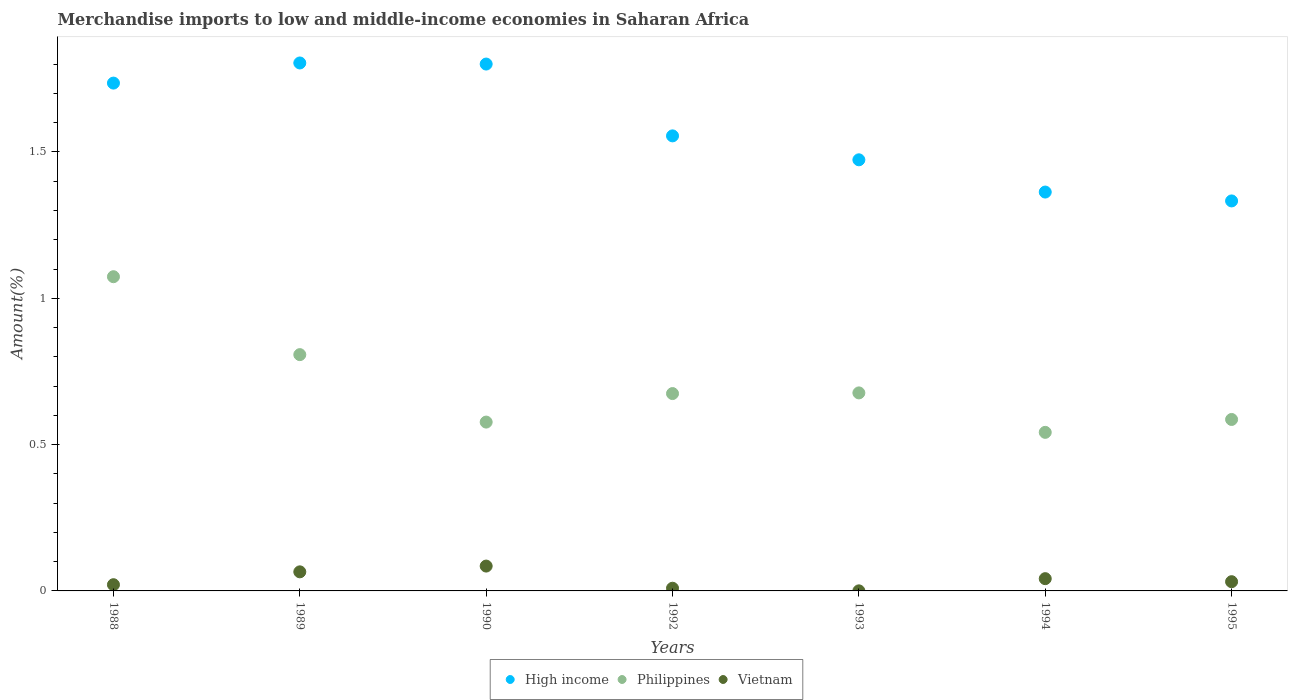How many different coloured dotlines are there?
Provide a short and direct response. 3. Is the number of dotlines equal to the number of legend labels?
Your answer should be compact. Yes. What is the percentage of amount earned from merchandise imports in High income in 1988?
Keep it short and to the point. 1.74. Across all years, what is the maximum percentage of amount earned from merchandise imports in Philippines?
Your response must be concise. 1.07. Across all years, what is the minimum percentage of amount earned from merchandise imports in Vietnam?
Your answer should be compact. 0. What is the total percentage of amount earned from merchandise imports in High income in the graph?
Offer a terse response. 11.06. What is the difference between the percentage of amount earned from merchandise imports in Vietnam in 1989 and that in 1992?
Your answer should be compact. 0.06. What is the difference between the percentage of amount earned from merchandise imports in High income in 1994 and the percentage of amount earned from merchandise imports in Vietnam in 1992?
Provide a succinct answer. 1.35. What is the average percentage of amount earned from merchandise imports in High income per year?
Your answer should be compact. 1.58. In the year 1993, what is the difference between the percentage of amount earned from merchandise imports in Vietnam and percentage of amount earned from merchandise imports in Philippines?
Offer a very short reply. -0.68. In how many years, is the percentage of amount earned from merchandise imports in Vietnam greater than 1.6 %?
Provide a succinct answer. 0. What is the ratio of the percentage of amount earned from merchandise imports in High income in 1988 to that in 1993?
Make the answer very short. 1.18. What is the difference between the highest and the second highest percentage of amount earned from merchandise imports in Vietnam?
Provide a short and direct response. 0.02. What is the difference between the highest and the lowest percentage of amount earned from merchandise imports in Vietnam?
Your answer should be compact. 0.08. How many years are there in the graph?
Your response must be concise. 7. Does the graph contain any zero values?
Give a very brief answer. No. Does the graph contain grids?
Your answer should be very brief. No. Where does the legend appear in the graph?
Your answer should be compact. Bottom center. How many legend labels are there?
Give a very brief answer. 3. How are the legend labels stacked?
Make the answer very short. Horizontal. What is the title of the graph?
Your response must be concise. Merchandise imports to low and middle-income economies in Saharan Africa. What is the label or title of the Y-axis?
Provide a succinct answer. Amount(%). What is the Amount(%) in High income in 1988?
Keep it short and to the point. 1.74. What is the Amount(%) of Philippines in 1988?
Give a very brief answer. 1.07. What is the Amount(%) in Vietnam in 1988?
Your response must be concise. 0.02. What is the Amount(%) in High income in 1989?
Provide a short and direct response. 1.8. What is the Amount(%) of Philippines in 1989?
Provide a succinct answer. 0.81. What is the Amount(%) in Vietnam in 1989?
Your answer should be compact. 0.07. What is the Amount(%) of High income in 1990?
Make the answer very short. 1.8. What is the Amount(%) in Philippines in 1990?
Your answer should be very brief. 0.58. What is the Amount(%) of Vietnam in 1990?
Give a very brief answer. 0.08. What is the Amount(%) of High income in 1992?
Ensure brevity in your answer.  1.56. What is the Amount(%) of Philippines in 1992?
Offer a terse response. 0.67. What is the Amount(%) of Vietnam in 1992?
Make the answer very short. 0.01. What is the Amount(%) of High income in 1993?
Give a very brief answer. 1.47. What is the Amount(%) of Philippines in 1993?
Ensure brevity in your answer.  0.68. What is the Amount(%) in Vietnam in 1993?
Provide a short and direct response. 0. What is the Amount(%) of High income in 1994?
Your answer should be compact. 1.36. What is the Amount(%) in Philippines in 1994?
Offer a terse response. 0.54. What is the Amount(%) in Vietnam in 1994?
Your answer should be compact. 0.04. What is the Amount(%) of High income in 1995?
Give a very brief answer. 1.33. What is the Amount(%) in Philippines in 1995?
Keep it short and to the point. 0.59. What is the Amount(%) in Vietnam in 1995?
Give a very brief answer. 0.03. Across all years, what is the maximum Amount(%) in High income?
Offer a very short reply. 1.8. Across all years, what is the maximum Amount(%) of Philippines?
Keep it short and to the point. 1.07. Across all years, what is the maximum Amount(%) in Vietnam?
Make the answer very short. 0.08. Across all years, what is the minimum Amount(%) in High income?
Make the answer very short. 1.33. Across all years, what is the minimum Amount(%) in Philippines?
Make the answer very short. 0.54. Across all years, what is the minimum Amount(%) of Vietnam?
Your answer should be compact. 0. What is the total Amount(%) in High income in the graph?
Give a very brief answer. 11.06. What is the total Amount(%) of Philippines in the graph?
Ensure brevity in your answer.  4.94. What is the total Amount(%) in Vietnam in the graph?
Provide a succinct answer. 0.25. What is the difference between the Amount(%) of High income in 1988 and that in 1989?
Provide a succinct answer. -0.07. What is the difference between the Amount(%) in Philippines in 1988 and that in 1989?
Offer a very short reply. 0.27. What is the difference between the Amount(%) in Vietnam in 1988 and that in 1989?
Provide a short and direct response. -0.04. What is the difference between the Amount(%) in High income in 1988 and that in 1990?
Make the answer very short. -0.07. What is the difference between the Amount(%) in Philippines in 1988 and that in 1990?
Give a very brief answer. 0.5. What is the difference between the Amount(%) of Vietnam in 1988 and that in 1990?
Offer a terse response. -0.06. What is the difference between the Amount(%) of High income in 1988 and that in 1992?
Keep it short and to the point. 0.18. What is the difference between the Amount(%) in Philippines in 1988 and that in 1992?
Your response must be concise. 0.4. What is the difference between the Amount(%) of Vietnam in 1988 and that in 1992?
Give a very brief answer. 0.01. What is the difference between the Amount(%) of High income in 1988 and that in 1993?
Your response must be concise. 0.26. What is the difference between the Amount(%) in Philippines in 1988 and that in 1993?
Provide a short and direct response. 0.4. What is the difference between the Amount(%) in Vietnam in 1988 and that in 1993?
Offer a very short reply. 0.02. What is the difference between the Amount(%) of High income in 1988 and that in 1994?
Provide a succinct answer. 0.37. What is the difference between the Amount(%) of Philippines in 1988 and that in 1994?
Ensure brevity in your answer.  0.53. What is the difference between the Amount(%) of Vietnam in 1988 and that in 1994?
Offer a terse response. -0.02. What is the difference between the Amount(%) in High income in 1988 and that in 1995?
Make the answer very short. 0.4. What is the difference between the Amount(%) of Philippines in 1988 and that in 1995?
Your answer should be very brief. 0.49. What is the difference between the Amount(%) in Vietnam in 1988 and that in 1995?
Offer a terse response. -0.01. What is the difference between the Amount(%) of High income in 1989 and that in 1990?
Offer a very short reply. 0. What is the difference between the Amount(%) of Philippines in 1989 and that in 1990?
Your answer should be compact. 0.23. What is the difference between the Amount(%) in Vietnam in 1989 and that in 1990?
Offer a very short reply. -0.02. What is the difference between the Amount(%) in High income in 1989 and that in 1992?
Provide a succinct answer. 0.25. What is the difference between the Amount(%) in Philippines in 1989 and that in 1992?
Make the answer very short. 0.13. What is the difference between the Amount(%) in Vietnam in 1989 and that in 1992?
Provide a succinct answer. 0.06. What is the difference between the Amount(%) of High income in 1989 and that in 1993?
Your answer should be very brief. 0.33. What is the difference between the Amount(%) in Philippines in 1989 and that in 1993?
Your answer should be very brief. 0.13. What is the difference between the Amount(%) in Vietnam in 1989 and that in 1993?
Make the answer very short. 0.06. What is the difference between the Amount(%) in High income in 1989 and that in 1994?
Your response must be concise. 0.44. What is the difference between the Amount(%) of Philippines in 1989 and that in 1994?
Make the answer very short. 0.27. What is the difference between the Amount(%) of Vietnam in 1989 and that in 1994?
Offer a very short reply. 0.02. What is the difference between the Amount(%) of High income in 1989 and that in 1995?
Keep it short and to the point. 0.47. What is the difference between the Amount(%) in Philippines in 1989 and that in 1995?
Your answer should be compact. 0.22. What is the difference between the Amount(%) of Vietnam in 1989 and that in 1995?
Offer a very short reply. 0.03. What is the difference between the Amount(%) of High income in 1990 and that in 1992?
Keep it short and to the point. 0.25. What is the difference between the Amount(%) in Philippines in 1990 and that in 1992?
Your answer should be very brief. -0.1. What is the difference between the Amount(%) of Vietnam in 1990 and that in 1992?
Give a very brief answer. 0.08. What is the difference between the Amount(%) of High income in 1990 and that in 1993?
Give a very brief answer. 0.33. What is the difference between the Amount(%) in Philippines in 1990 and that in 1993?
Your answer should be very brief. -0.1. What is the difference between the Amount(%) in Vietnam in 1990 and that in 1993?
Provide a short and direct response. 0.08. What is the difference between the Amount(%) of High income in 1990 and that in 1994?
Your answer should be very brief. 0.44. What is the difference between the Amount(%) of Philippines in 1990 and that in 1994?
Your answer should be very brief. 0.04. What is the difference between the Amount(%) of Vietnam in 1990 and that in 1994?
Keep it short and to the point. 0.04. What is the difference between the Amount(%) of High income in 1990 and that in 1995?
Ensure brevity in your answer.  0.47. What is the difference between the Amount(%) of Philippines in 1990 and that in 1995?
Provide a short and direct response. -0.01. What is the difference between the Amount(%) of Vietnam in 1990 and that in 1995?
Offer a terse response. 0.05. What is the difference between the Amount(%) in High income in 1992 and that in 1993?
Give a very brief answer. 0.08. What is the difference between the Amount(%) of Philippines in 1992 and that in 1993?
Your answer should be very brief. -0. What is the difference between the Amount(%) of Vietnam in 1992 and that in 1993?
Keep it short and to the point. 0.01. What is the difference between the Amount(%) in High income in 1992 and that in 1994?
Ensure brevity in your answer.  0.19. What is the difference between the Amount(%) of Philippines in 1992 and that in 1994?
Your response must be concise. 0.13. What is the difference between the Amount(%) of Vietnam in 1992 and that in 1994?
Ensure brevity in your answer.  -0.03. What is the difference between the Amount(%) in High income in 1992 and that in 1995?
Make the answer very short. 0.22. What is the difference between the Amount(%) of Philippines in 1992 and that in 1995?
Make the answer very short. 0.09. What is the difference between the Amount(%) of Vietnam in 1992 and that in 1995?
Offer a very short reply. -0.02. What is the difference between the Amount(%) of High income in 1993 and that in 1994?
Make the answer very short. 0.11. What is the difference between the Amount(%) in Philippines in 1993 and that in 1994?
Provide a succinct answer. 0.13. What is the difference between the Amount(%) of Vietnam in 1993 and that in 1994?
Offer a very short reply. -0.04. What is the difference between the Amount(%) of High income in 1993 and that in 1995?
Ensure brevity in your answer.  0.14. What is the difference between the Amount(%) in Philippines in 1993 and that in 1995?
Give a very brief answer. 0.09. What is the difference between the Amount(%) in Vietnam in 1993 and that in 1995?
Provide a succinct answer. -0.03. What is the difference between the Amount(%) of High income in 1994 and that in 1995?
Make the answer very short. 0.03. What is the difference between the Amount(%) of Philippines in 1994 and that in 1995?
Give a very brief answer. -0.04. What is the difference between the Amount(%) in Vietnam in 1994 and that in 1995?
Keep it short and to the point. 0.01. What is the difference between the Amount(%) of High income in 1988 and the Amount(%) of Philippines in 1989?
Provide a short and direct response. 0.93. What is the difference between the Amount(%) of High income in 1988 and the Amount(%) of Vietnam in 1989?
Offer a very short reply. 1.67. What is the difference between the Amount(%) of Philippines in 1988 and the Amount(%) of Vietnam in 1989?
Your answer should be very brief. 1.01. What is the difference between the Amount(%) of High income in 1988 and the Amount(%) of Philippines in 1990?
Make the answer very short. 1.16. What is the difference between the Amount(%) in High income in 1988 and the Amount(%) in Vietnam in 1990?
Your answer should be very brief. 1.65. What is the difference between the Amount(%) of Philippines in 1988 and the Amount(%) of Vietnam in 1990?
Provide a short and direct response. 0.99. What is the difference between the Amount(%) in High income in 1988 and the Amount(%) in Philippines in 1992?
Your response must be concise. 1.06. What is the difference between the Amount(%) of High income in 1988 and the Amount(%) of Vietnam in 1992?
Your answer should be very brief. 1.73. What is the difference between the Amount(%) in Philippines in 1988 and the Amount(%) in Vietnam in 1992?
Offer a very short reply. 1.06. What is the difference between the Amount(%) in High income in 1988 and the Amount(%) in Philippines in 1993?
Give a very brief answer. 1.06. What is the difference between the Amount(%) in High income in 1988 and the Amount(%) in Vietnam in 1993?
Keep it short and to the point. 1.74. What is the difference between the Amount(%) in Philippines in 1988 and the Amount(%) in Vietnam in 1993?
Your answer should be very brief. 1.07. What is the difference between the Amount(%) in High income in 1988 and the Amount(%) in Philippines in 1994?
Ensure brevity in your answer.  1.19. What is the difference between the Amount(%) of High income in 1988 and the Amount(%) of Vietnam in 1994?
Offer a terse response. 1.69. What is the difference between the Amount(%) of Philippines in 1988 and the Amount(%) of Vietnam in 1994?
Keep it short and to the point. 1.03. What is the difference between the Amount(%) of High income in 1988 and the Amount(%) of Philippines in 1995?
Provide a succinct answer. 1.15. What is the difference between the Amount(%) in High income in 1988 and the Amount(%) in Vietnam in 1995?
Your answer should be very brief. 1.7. What is the difference between the Amount(%) in Philippines in 1988 and the Amount(%) in Vietnam in 1995?
Ensure brevity in your answer.  1.04. What is the difference between the Amount(%) in High income in 1989 and the Amount(%) in Philippines in 1990?
Make the answer very short. 1.23. What is the difference between the Amount(%) in High income in 1989 and the Amount(%) in Vietnam in 1990?
Give a very brief answer. 1.72. What is the difference between the Amount(%) of Philippines in 1989 and the Amount(%) of Vietnam in 1990?
Ensure brevity in your answer.  0.72. What is the difference between the Amount(%) of High income in 1989 and the Amount(%) of Philippines in 1992?
Keep it short and to the point. 1.13. What is the difference between the Amount(%) in High income in 1989 and the Amount(%) in Vietnam in 1992?
Make the answer very short. 1.79. What is the difference between the Amount(%) of Philippines in 1989 and the Amount(%) of Vietnam in 1992?
Offer a very short reply. 0.8. What is the difference between the Amount(%) in High income in 1989 and the Amount(%) in Philippines in 1993?
Your answer should be compact. 1.13. What is the difference between the Amount(%) of High income in 1989 and the Amount(%) of Vietnam in 1993?
Make the answer very short. 1.8. What is the difference between the Amount(%) in Philippines in 1989 and the Amount(%) in Vietnam in 1993?
Provide a succinct answer. 0.81. What is the difference between the Amount(%) in High income in 1989 and the Amount(%) in Philippines in 1994?
Provide a succinct answer. 1.26. What is the difference between the Amount(%) of High income in 1989 and the Amount(%) of Vietnam in 1994?
Your answer should be compact. 1.76. What is the difference between the Amount(%) of Philippines in 1989 and the Amount(%) of Vietnam in 1994?
Offer a very short reply. 0.77. What is the difference between the Amount(%) of High income in 1989 and the Amount(%) of Philippines in 1995?
Provide a short and direct response. 1.22. What is the difference between the Amount(%) of High income in 1989 and the Amount(%) of Vietnam in 1995?
Provide a short and direct response. 1.77. What is the difference between the Amount(%) in Philippines in 1989 and the Amount(%) in Vietnam in 1995?
Your response must be concise. 0.78. What is the difference between the Amount(%) in High income in 1990 and the Amount(%) in Philippines in 1992?
Give a very brief answer. 1.13. What is the difference between the Amount(%) of High income in 1990 and the Amount(%) of Vietnam in 1992?
Give a very brief answer. 1.79. What is the difference between the Amount(%) in Philippines in 1990 and the Amount(%) in Vietnam in 1992?
Make the answer very short. 0.57. What is the difference between the Amount(%) in High income in 1990 and the Amount(%) in Philippines in 1993?
Offer a very short reply. 1.12. What is the difference between the Amount(%) in High income in 1990 and the Amount(%) in Vietnam in 1993?
Provide a succinct answer. 1.8. What is the difference between the Amount(%) in Philippines in 1990 and the Amount(%) in Vietnam in 1993?
Keep it short and to the point. 0.58. What is the difference between the Amount(%) in High income in 1990 and the Amount(%) in Philippines in 1994?
Your response must be concise. 1.26. What is the difference between the Amount(%) in High income in 1990 and the Amount(%) in Vietnam in 1994?
Your answer should be compact. 1.76. What is the difference between the Amount(%) of Philippines in 1990 and the Amount(%) of Vietnam in 1994?
Your answer should be compact. 0.54. What is the difference between the Amount(%) of High income in 1990 and the Amount(%) of Philippines in 1995?
Ensure brevity in your answer.  1.21. What is the difference between the Amount(%) in High income in 1990 and the Amount(%) in Vietnam in 1995?
Offer a terse response. 1.77. What is the difference between the Amount(%) in Philippines in 1990 and the Amount(%) in Vietnam in 1995?
Your response must be concise. 0.55. What is the difference between the Amount(%) of High income in 1992 and the Amount(%) of Philippines in 1993?
Your answer should be very brief. 0.88. What is the difference between the Amount(%) of High income in 1992 and the Amount(%) of Vietnam in 1993?
Give a very brief answer. 1.55. What is the difference between the Amount(%) of Philippines in 1992 and the Amount(%) of Vietnam in 1993?
Make the answer very short. 0.67. What is the difference between the Amount(%) of High income in 1992 and the Amount(%) of Philippines in 1994?
Offer a terse response. 1.01. What is the difference between the Amount(%) of High income in 1992 and the Amount(%) of Vietnam in 1994?
Provide a short and direct response. 1.51. What is the difference between the Amount(%) in Philippines in 1992 and the Amount(%) in Vietnam in 1994?
Ensure brevity in your answer.  0.63. What is the difference between the Amount(%) in High income in 1992 and the Amount(%) in Philippines in 1995?
Keep it short and to the point. 0.97. What is the difference between the Amount(%) in High income in 1992 and the Amount(%) in Vietnam in 1995?
Ensure brevity in your answer.  1.52. What is the difference between the Amount(%) in Philippines in 1992 and the Amount(%) in Vietnam in 1995?
Offer a very short reply. 0.64. What is the difference between the Amount(%) in High income in 1993 and the Amount(%) in Philippines in 1994?
Give a very brief answer. 0.93. What is the difference between the Amount(%) of High income in 1993 and the Amount(%) of Vietnam in 1994?
Give a very brief answer. 1.43. What is the difference between the Amount(%) in Philippines in 1993 and the Amount(%) in Vietnam in 1994?
Keep it short and to the point. 0.63. What is the difference between the Amount(%) of High income in 1993 and the Amount(%) of Philippines in 1995?
Your answer should be very brief. 0.89. What is the difference between the Amount(%) in High income in 1993 and the Amount(%) in Vietnam in 1995?
Make the answer very short. 1.44. What is the difference between the Amount(%) in Philippines in 1993 and the Amount(%) in Vietnam in 1995?
Provide a short and direct response. 0.65. What is the difference between the Amount(%) in High income in 1994 and the Amount(%) in Philippines in 1995?
Offer a very short reply. 0.78. What is the difference between the Amount(%) in High income in 1994 and the Amount(%) in Vietnam in 1995?
Provide a succinct answer. 1.33. What is the difference between the Amount(%) of Philippines in 1994 and the Amount(%) of Vietnam in 1995?
Your response must be concise. 0.51. What is the average Amount(%) of High income per year?
Offer a very short reply. 1.58. What is the average Amount(%) in Philippines per year?
Offer a terse response. 0.71. What is the average Amount(%) of Vietnam per year?
Provide a short and direct response. 0.04. In the year 1988, what is the difference between the Amount(%) of High income and Amount(%) of Philippines?
Make the answer very short. 0.66. In the year 1988, what is the difference between the Amount(%) of High income and Amount(%) of Vietnam?
Your response must be concise. 1.71. In the year 1988, what is the difference between the Amount(%) in Philippines and Amount(%) in Vietnam?
Offer a terse response. 1.05. In the year 1989, what is the difference between the Amount(%) in High income and Amount(%) in Philippines?
Ensure brevity in your answer.  1. In the year 1989, what is the difference between the Amount(%) in High income and Amount(%) in Vietnam?
Your answer should be compact. 1.74. In the year 1989, what is the difference between the Amount(%) in Philippines and Amount(%) in Vietnam?
Your answer should be very brief. 0.74. In the year 1990, what is the difference between the Amount(%) in High income and Amount(%) in Philippines?
Make the answer very short. 1.22. In the year 1990, what is the difference between the Amount(%) in High income and Amount(%) in Vietnam?
Provide a succinct answer. 1.72. In the year 1990, what is the difference between the Amount(%) in Philippines and Amount(%) in Vietnam?
Provide a succinct answer. 0.49. In the year 1992, what is the difference between the Amount(%) of High income and Amount(%) of Philippines?
Your response must be concise. 0.88. In the year 1992, what is the difference between the Amount(%) in High income and Amount(%) in Vietnam?
Make the answer very short. 1.55. In the year 1992, what is the difference between the Amount(%) of Philippines and Amount(%) of Vietnam?
Make the answer very short. 0.67. In the year 1993, what is the difference between the Amount(%) of High income and Amount(%) of Philippines?
Your answer should be compact. 0.8. In the year 1993, what is the difference between the Amount(%) of High income and Amount(%) of Vietnam?
Offer a terse response. 1.47. In the year 1993, what is the difference between the Amount(%) in Philippines and Amount(%) in Vietnam?
Provide a succinct answer. 0.68. In the year 1994, what is the difference between the Amount(%) of High income and Amount(%) of Philippines?
Your response must be concise. 0.82. In the year 1994, what is the difference between the Amount(%) in High income and Amount(%) in Vietnam?
Your answer should be compact. 1.32. In the year 1994, what is the difference between the Amount(%) in Philippines and Amount(%) in Vietnam?
Provide a succinct answer. 0.5. In the year 1995, what is the difference between the Amount(%) of High income and Amount(%) of Philippines?
Make the answer very short. 0.75. In the year 1995, what is the difference between the Amount(%) of High income and Amount(%) of Vietnam?
Your answer should be very brief. 1.3. In the year 1995, what is the difference between the Amount(%) of Philippines and Amount(%) of Vietnam?
Give a very brief answer. 0.55. What is the ratio of the Amount(%) of High income in 1988 to that in 1989?
Your response must be concise. 0.96. What is the ratio of the Amount(%) of Philippines in 1988 to that in 1989?
Give a very brief answer. 1.33. What is the ratio of the Amount(%) in Vietnam in 1988 to that in 1989?
Offer a very short reply. 0.33. What is the ratio of the Amount(%) in High income in 1988 to that in 1990?
Provide a succinct answer. 0.96. What is the ratio of the Amount(%) in Philippines in 1988 to that in 1990?
Give a very brief answer. 1.86. What is the ratio of the Amount(%) of Vietnam in 1988 to that in 1990?
Your answer should be compact. 0.25. What is the ratio of the Amount(%) in High income in 1988 to that in 1992?
Provide a succinct answer. 1.12. What is the ratio of the Amount(%) in Philippines in 1988 to that in 1992?
Make the answer very short. 1.59. What is the ratio of the Amount(%) in Vietnam in 1988 to that in 1992?
Your answer should be very brief. 2.31. What is the ratio of the Amount(%) of High income in 1988 to that in 1993?
Ensure brevity in your answer.  1.18. What is the ratio of the Amount(%) of Philippines in 1988 to that in 1993?
Provide a short and direct response. 1.59. What is the ratio of the Amount(%) of Vietnam in 1988 to that in 1993?
Ensure brevity in your answer.  83.41. What is the ratio of the Amount(%) in High income in 1988 to that in 1994?
Your response must be concise. 1.27. What is the ratio of the Amount(%) of Philippines in 1988 to that in 1994?
Keep it short and to the point. 1.98. What is the ratio of the Amount(%) of Vietnam in 1988 to that in 1994?
Offer a terse response. 0.51. What is the ratio of the Amount(%) in High income in 1988 to that in 1995?
Offer a terse response. 1.3. What is the ratio of the Amount(%) in Philippines in 1988 to that in 1995?
Ensure brevity in your answer.  1.83. What is the ratio of the Amount(%) of Vietnam in 1988 to that in 1995?
Your answer should be compact. 0.67. What is the ratio of the Amount(%) in Philippines in 1989 to that in 1990?
Your answer should be compact. 1.4. What is the ratio of the Amount(%) of Vietnam in 1989 to that in 1990?
Make the answer very short. 0.77. What is the ratio of the Amount(%) of High income in 1989 to that in 1992?
Make the answer very short. 1.16. What is the ratio of the Amount(%) in Philippines in 1989 to that in 1992?
Your response must be concise. 1.2. What is the ratio of the Amount(%) of Vietnam in 1989 to that in 1992?
Give a very brief answer. 7.1. What is the ratio of the Amount(%) in High income in 1989 to that in 1993?
Make the answer very short. 1.22. What is the ratio of the Amount(%) in Philippines in 1989 to that in 1993?
Your answer should be very brief. 1.19. What is the ratio of the Amount(%) of Vietnam in 1989 to that in 1993?
Your response must be concise. 255.85. What is the ratio of the Amount(%) of High income in 1989 to that in 1994?
Ensure brevity in your answer.  1.32. What is the ratio of the Amount(%) in Philippines in 1989 to that in 1994?
Make the answer very short. 1.49. What is the ratio of the Amount(%) in Vietnam in 1989 to that in 1994?
Your response must be concise. 1.56. What is the ratio of the Amount(%) of High income in 1989 to that in 1995?
Keep it short and to the point. 1.35. What is the ratio of the Amount(%) in Philippines in 1989 to that in 1995?
Offer a very short reply. 1.38. What is the ratio of the Amount(%) in Vietnam in 1989 to that in 1995?
Make the answer very short. 2.07. What is the ratio of the Amount(%) in High income in 1990 to that in 1992?
Provide a short and direct response. 1.16. What is the ratio of the Amount(%) of Philippines in 1990 to that in 1992?
Offer a very short reply. 0.86. What is the ratio of the Amount(%) of Vietnam in 1990 to that in 1992?
Offer a terse response. 9.25. What is the ratio of the Amount(%) in High income in 1990 to that in 1993?
Ensure brevity in your answer.  1.22. What is the ratio of the Amount(%) in Philippines in 1990 to that in 1993?
Offer a very short reply. 0.85. What is the ratio of the Amount(%) of Vietnam in 1990 to that in 1993?
Your answer should be compact. 333.15. What is the ratio of the Amount(%) in High income in 1990 to that in 1994?
Your answer should be very brief. 1.32. What is the ratio of the Amount(%) in Philippines in 1990 to that in 1994?
Offer a terse response. 1.06. What is the ratio of the Amount(%) of Vietnam in 1990 to that in 1994?
Provide a short and direct response. 2.03. What is the ratio of the Amount(%) of High income in 1990 to that in 1995?
Ensure brevity in your answer.  1.35. What is the ratio of the Amount(%) of Philippines in 1990 to that in 1995?
Give a very brief answer. 0.98. What is the ratio of the Amount(%) in Vietnam in 1990 to that in 1995?
Offer a very short reply. 2.69. What is the ratio of the Amount(%) in High income in 1992 to that in 1993?
Your response must be concise. 1.06. What is the ratio of the Amount(%) of Vietnam in 1992 to that in 1993?
Ensure brevity in your answer.  36.03. What is the ratio of the Amount(%) in High income in 1992 to that in 1994?
Offer a very short reply. 1.14. What is the ratio of the Amount(%) in Philippines in 1992 to that in 1994?
Give a very brief answer. 1.24. What is the ratio of the Amount(%) in Vietnam in 1992 to that in 1994?
Give a very brief answer. 0.22. What is the ratio of the Amount(%) in High income in 1992 to that in 1995?
Offer a terse response. 1.17. What is the ratio of the Amount(%) of Philippines in 1992 to that in 1995?
Make the answer very short. 1.15. What is the ratio of the Amount(%) in Vietnam in 1992 to that in 1995?
Offer a very short reply. 0.29. What is the ratio of the Amount(%) in High income in 1993 to that in 1994?
Your response must be concise. 1.08. What is the ratio of the Amount(%) in Philippines in 1993 to that in 1994?
Ensure brevity in your answer.  1.25. What is the ratio of the Amount(%) in Vietnam in 1993 to that in 1994?
Your response must be concise. 0.01. What is the ratio of the Amount(%) in High income in 1993 to that in 1995?
Provide a short and direct response. 1.11. What is the ratio of the Amount(%) in Philippines in 1993 to that in 1995?
Provide a succinct answer. 1.16. What is the ratio of the Amount(%) in Vietnam in 1993 to that in 1995?
Ensure brevity in your answer.  0.01. What is the ratio of the Amount(%) of High income in 1994 to that in 1995?
Your answer should be compact. 1.02. What is the ratio of the Amount(%) of Philippines in 1994 to that in 1995?
Provide a short and direct response. 0.92. What is the ratio of the Amount(%) in Vietnam in 1994 to that in 1995?
Offer a terse response. 1.33. What is the difference between the highest and the second highest Amount(%) in High income?
Your answer should be very brief. 0. What is the difference between the highest and the second highest Amount(%) in Philippines?
Keep it short and to the point. 0.27. What is the difference between the highest and the second highest Amount(%) of Vietnam?
Ensure brevity in your answer.  0.02. What is the difference between the highest and the lowest Amount(%) in High income?
Your answer should be very brief. 0.47. What is the difference between the highest and the lowest Amount(%) of Philippines?
Make the answer very short. 0.53. What is the difference between the highest and the lowest Amount(%) in Vietnam?
Your answer should be compact. 0.08. 